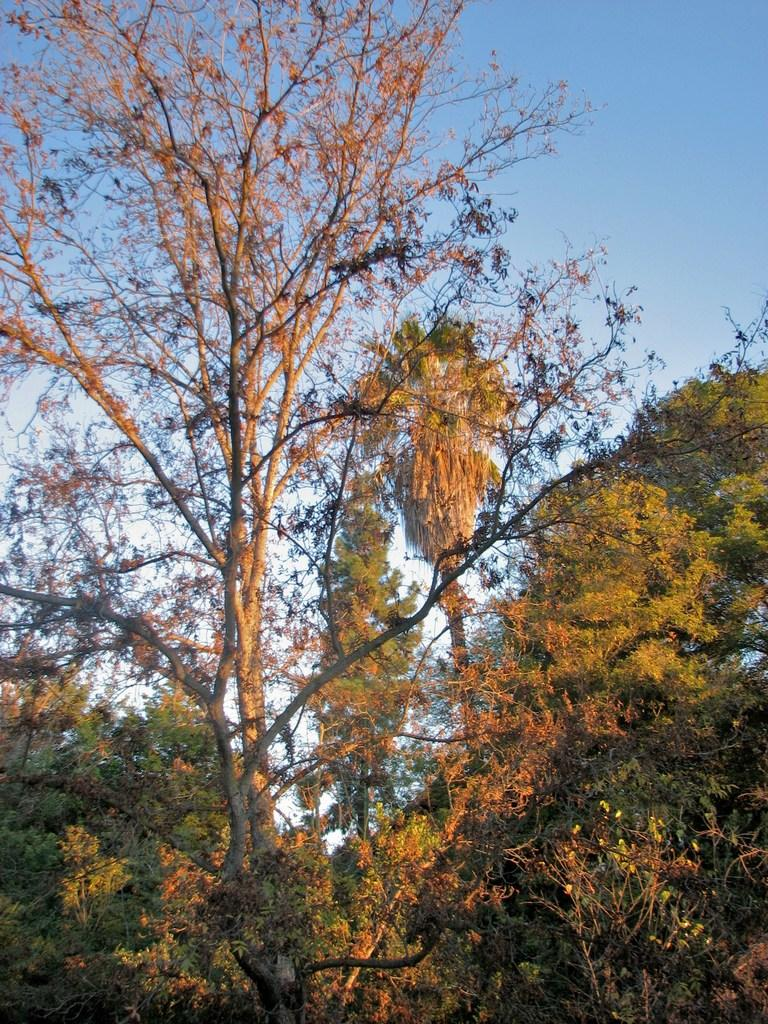What type of vegetation or plants can be seen in the foreground of the image? There is greenery in the foreground of the image. What part of the natural environment is visible in the background of the image? The sky is visible in the background of the image. Can you see a pig in the neck of the rainstorm in the image? There is no pig or rainstorm present in the image. The image only features greenery in the foreground and the sky in the background. 